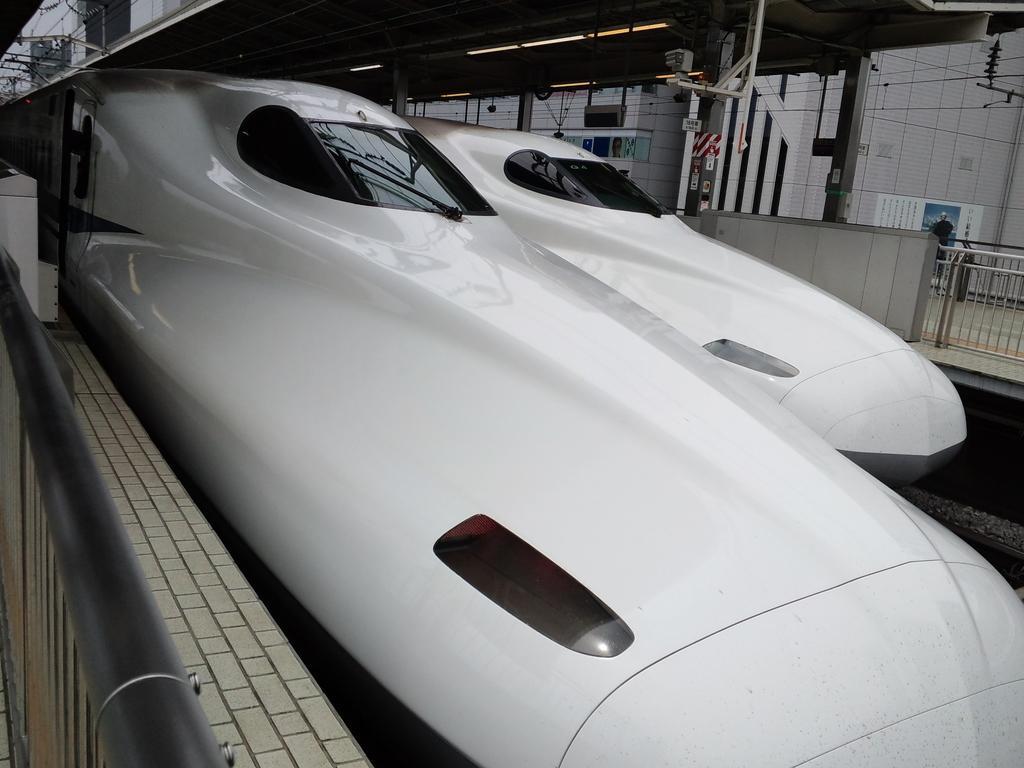Please provide a concise description of this image. In this image, I can see two bullet trains. On the left side of the image, I can see an iron pole and a wall. On the right side of the image, there is a building, platform, barricade, poles and lights. 